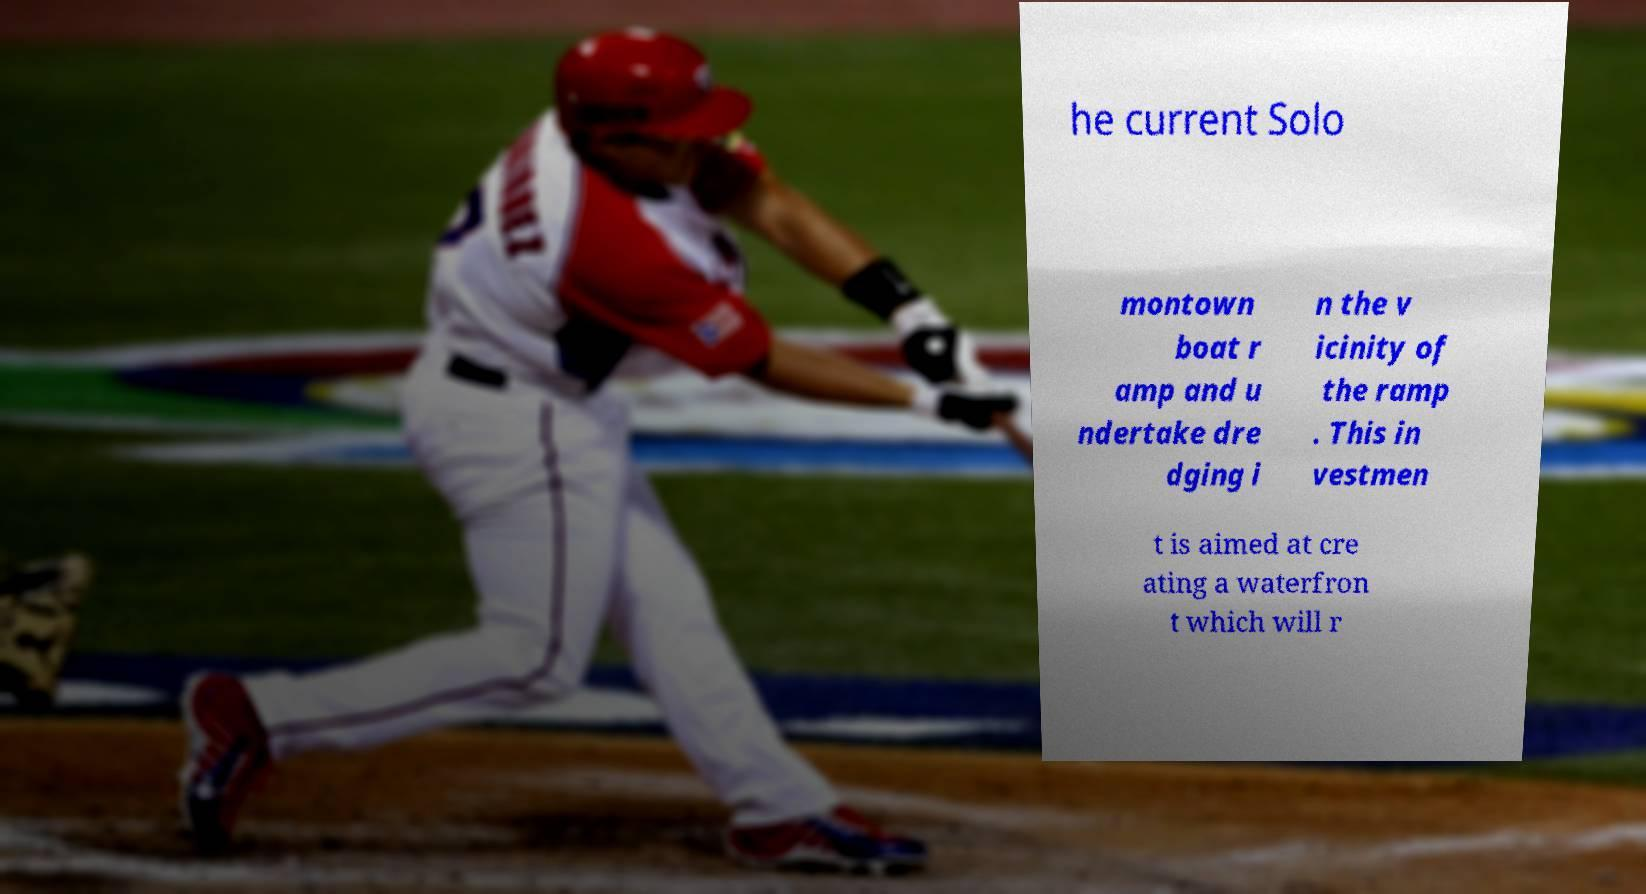Can you read and provide the text displayed in the image?This photo seems to have some interesting text. Can you extract and type it out for me? he current Solo montown boat r amp and u ndertake dre dging i n the v icinity of the ramp . This in vestmen t is aimed at cre ating a waterfron t which will r 